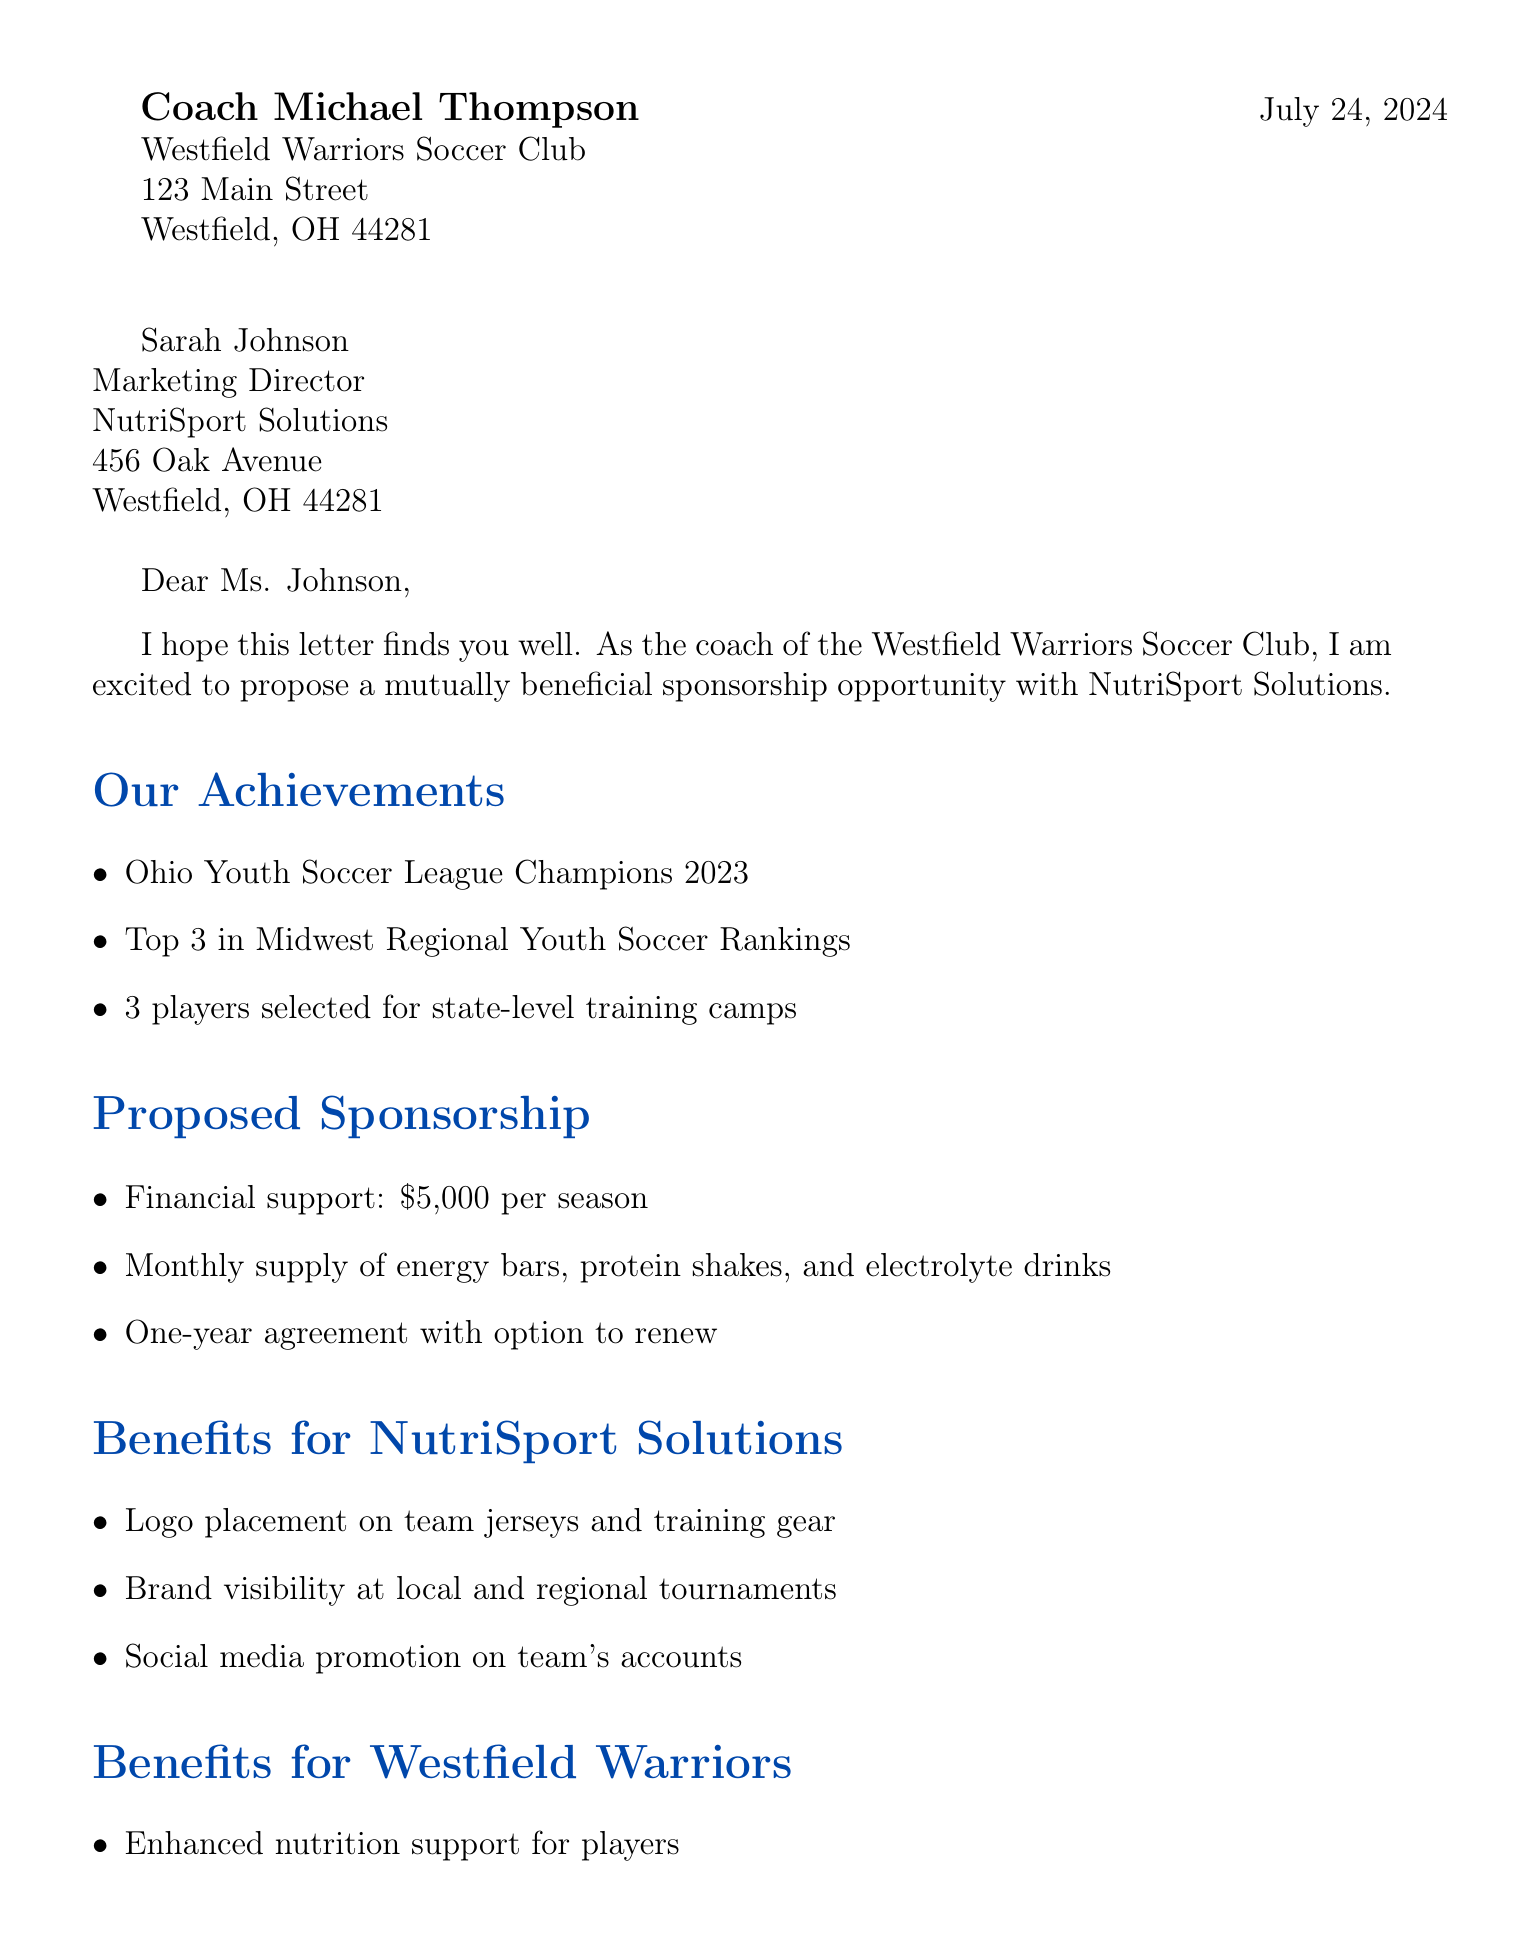what is the financial support offered? The document clearly states the amount of financial support that will be provided to the team.
Answer: $5,000 per season who is the Marketing Director? The document mentions the recipient's name and position.
Answer: Sarah Johnson what are the product samples provided each month? The document lists specific nutritional products that are included in the sponsorship agreement.
Answer: energy bars, protein shakes, and electrolyte drinks what is the duration of the sponsorship agreement? The document specifies how long the agreement will last and any renewal options.
Answer: One-year agreement with option to renew what recent achievement did the team attain in 2023? The document highlights the team's success in a specific competition.
Answer: Ohio Youth Soccer League Champions 2023 what benefits will NutriSport Solutions receive? The document outlines specific advantages for the sponsor as part of the agreement.
Answer: Logo placement on team jerseys and training gear when is the proposed meeting date? The document suggests a specific date for a follow-up discussion about the sponsorship.
Answer: Next Tuesday at 2:00 PM where will the meeting take place? The document indicates the location for the proposed meeting.
Answer: Westfield Community Center how many players were selected for state-level training camps? The document provides a specific number related to player development achievements.
Answer: 3 players 